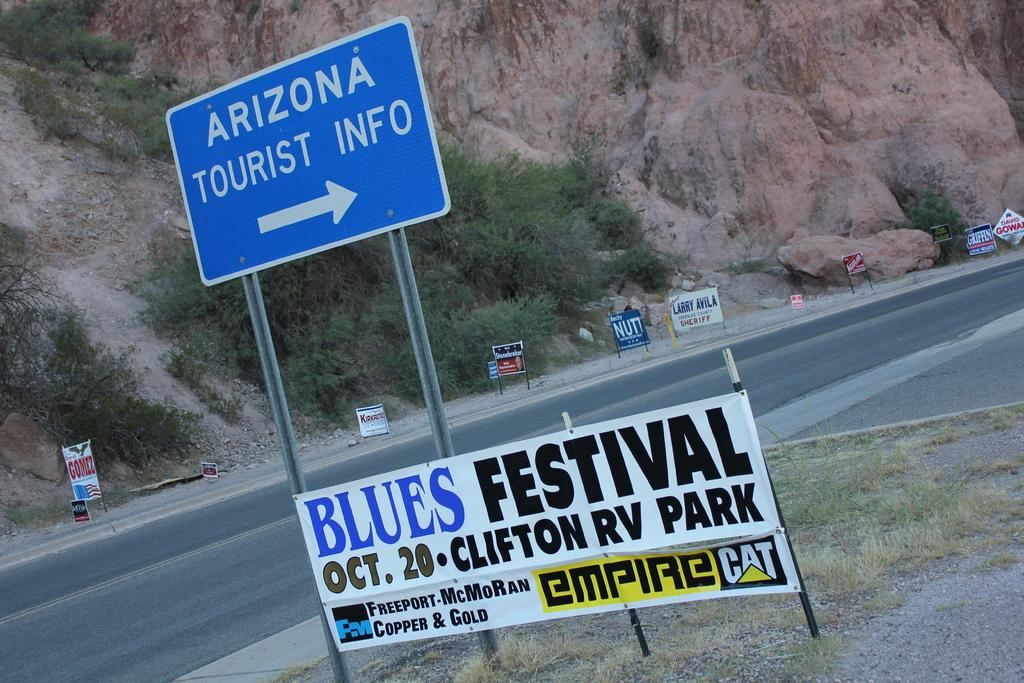Provide a one-sentence caption for the provided image. A sign posted by the highway promoting a "Blues Festival". 